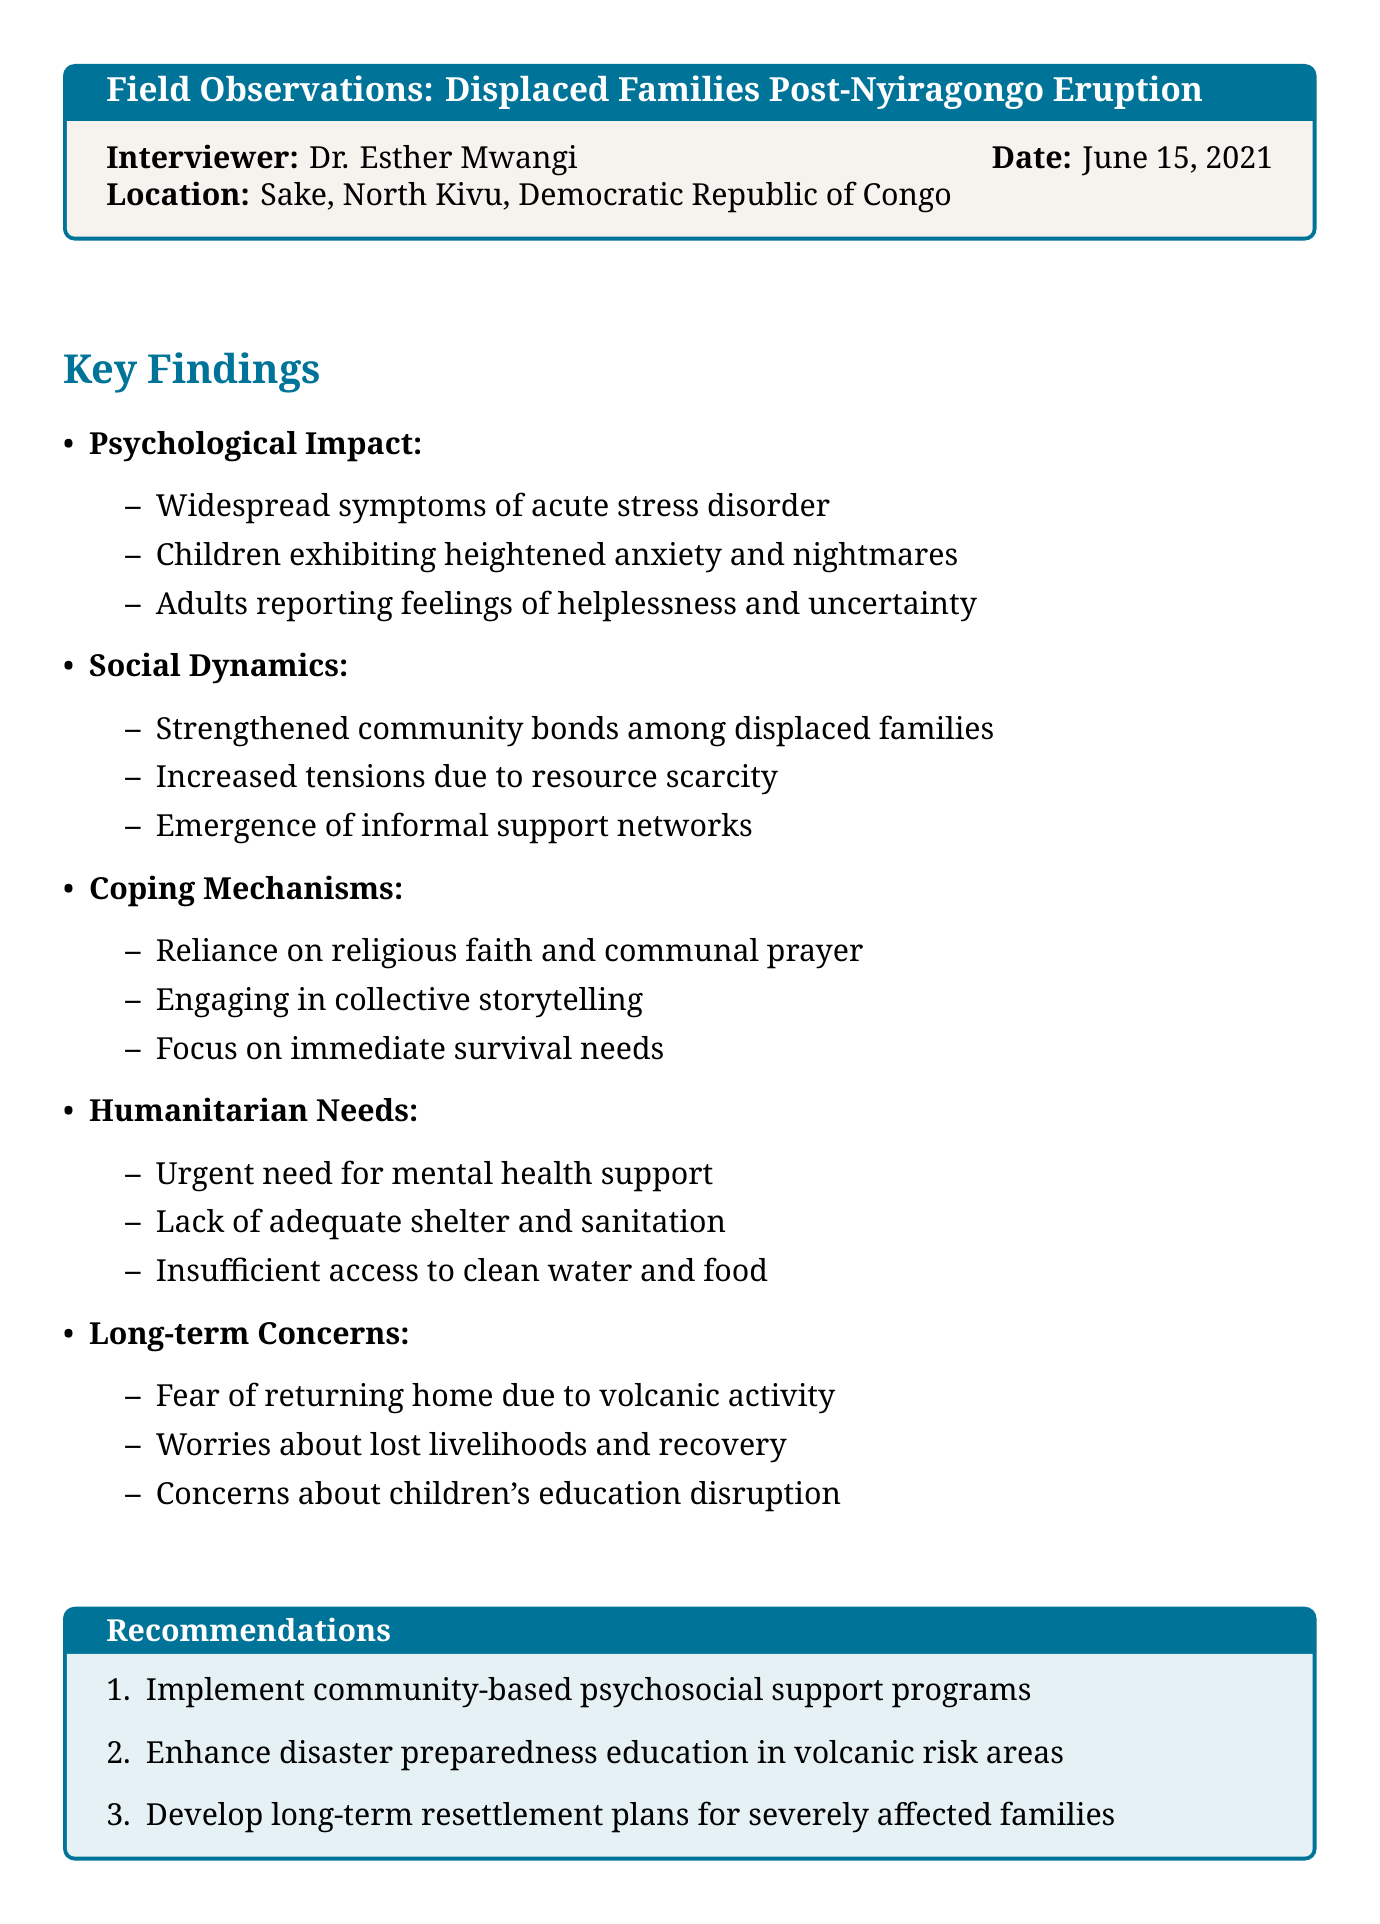What date was the interview conducted? The date of the interview is clearly stated in the document as June 15, 2021.
Answer: June 15, 2021 Who was the interviewer? The interviewer's name is mentioned in the document, which is Dr. Esther Mwangi.
Answer: Dr. Esther Mwangi What is one key finding related to psychological impact? One observation on psychological impact is that there are "Widespread symptoms of acute stress disorder."
Answer: Widespread symptoms of acute stress disorder What is a noted coping mechanism among displaced families? The document lists several coping mechanisms, one of which is "Reliance on religious faith and communal prayer."
Answer: Reliance on religious faith and communal prayer What humanitarian need is mentioned as urgent? The document emphasizes the "Urgent need for mental health support and counseling services."
Answer: Urgent need for mental health support and counseling services What is a long-term concern for the affected families? The document illustrates several long-term concerns, including "Fear of returning home due to ongoing volcanic activity."
Answer: Fear of returning home due to ongoing volcanic activity What is one recommendation provided in the document? One recommendation for addressing the situation is to "Implement community-based psychosocial support programs."
Answer: Implement community-based psychosocial support programs How many categories of key findings are identified? The document outlines five different categories of key findings related to the displaced families.
Answer: Five 